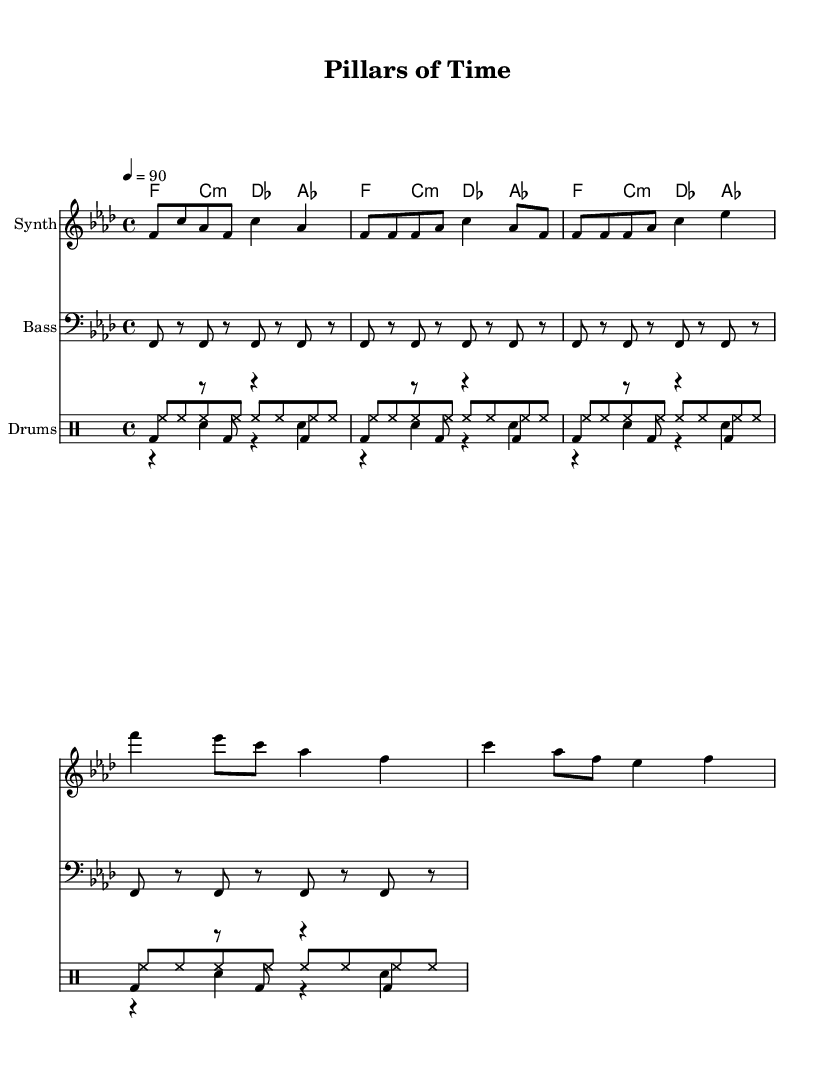What is the key signature of this music? The key signature is indicated at the beginning of the sheet music. In this case, it shows F minor, which typically comprises four flats.
Answer: F minor What is the time signature of this music? The time signature is located at the beginning of the score, typically represented by two numbers. Here, it is 4/4, meaning there are four beats in a measure and the quarter note gets one beat.
Answer: 4/4 What is the tempo marking for this music? The tempo marking can be found indicated after the time signature. The marking states "4 = 90," which means the quarter note is set to a tempo of 90 beats per minute.
Answer: 90 How many measures are in the Chorus section? To determine the number of measures in the Chorus section, one must count the measures in that part, which are typically marked or recognizable through structure or lyrics. There are four measures in the Chorus.
Answer: 4 What instrument is used for the melody in this music? The instrument name for the melody part is specified at the beginning of the respective staff, which shows "Synth." Thus, the melody is played on a synthesizer.
Answer: Synth What is the rhythm pattern of the kick drum in the drum section? By analyzing the notations under the drum patterns, the kick drum pattern shows four repeated notes during its part. This indicates a regular kick drum rhythm that aligns with the Hip Hop style.
Answer: bd4 What architectural marvel might this song celebrate? Given that the song is titled "Pillars of Time," one would infer it possibly celebrates monumental structures such as the architectural wonders of ancient civilization like the Great Pyramid of Giza.
Answer: Great Pyramid of Giza 